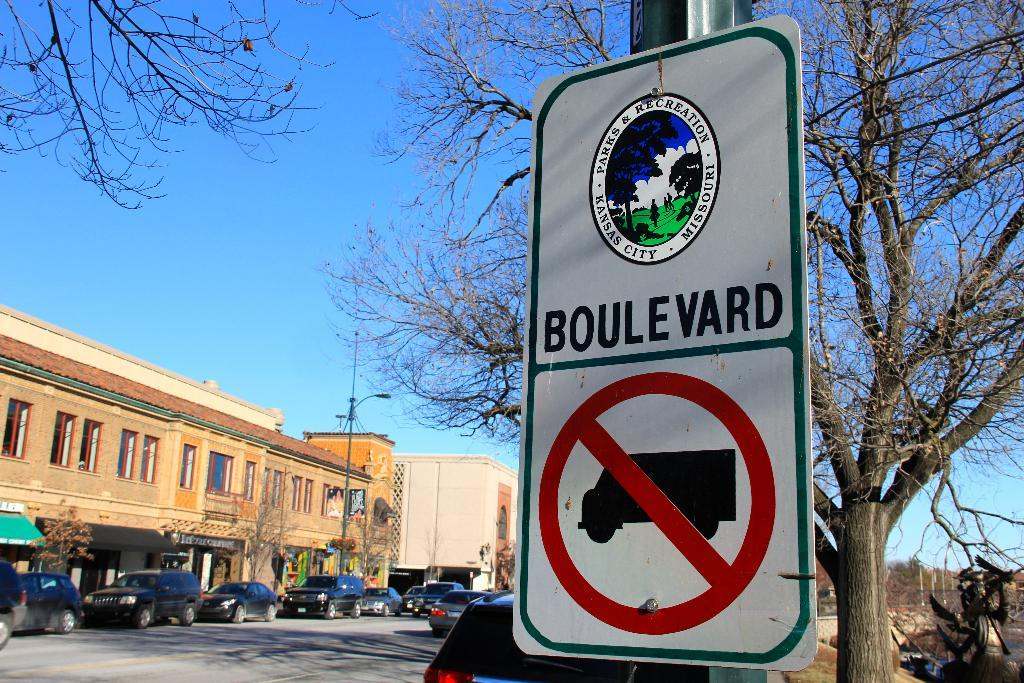<image>
Relay a brief, clear account of the picture shown. a sign that has the word Boulevard on it 